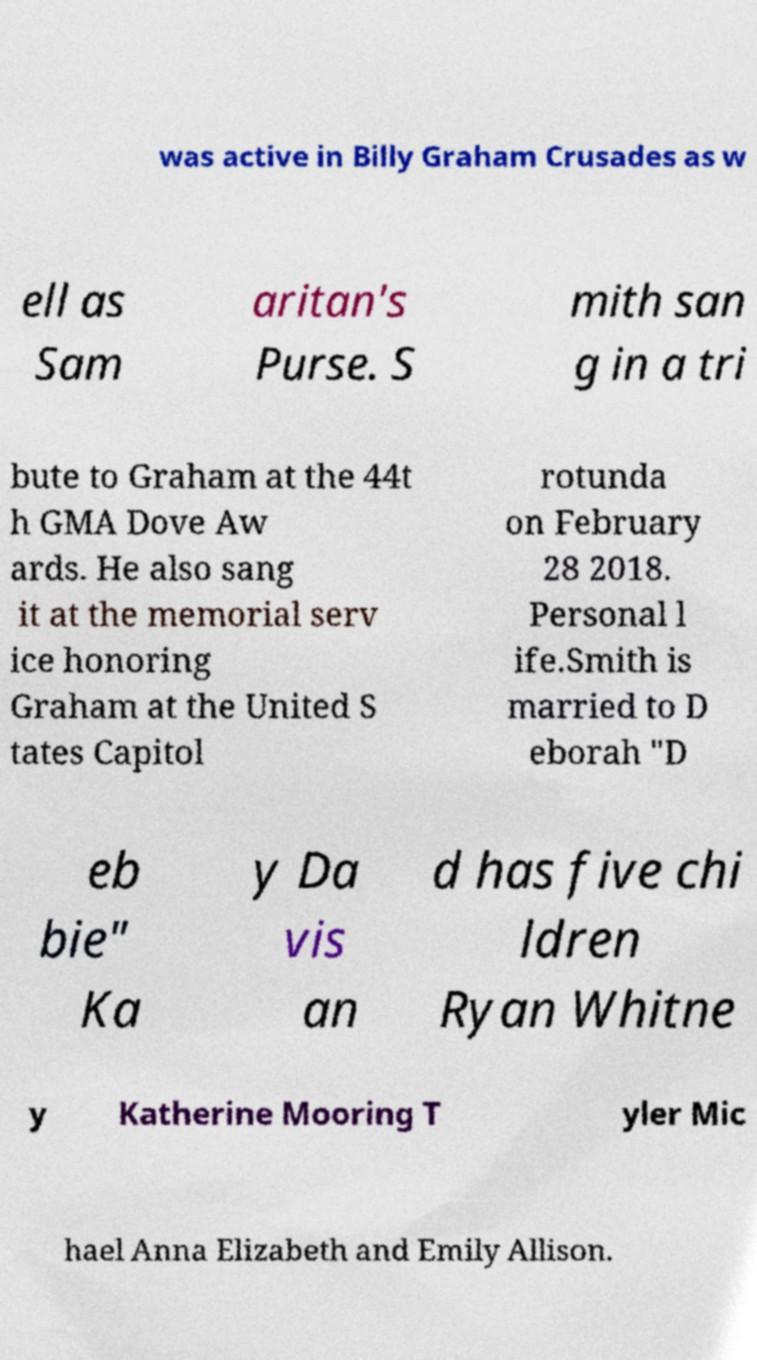Please read and relay the text visible in this image. What does it say? was active in Billy Graham Crusades as w ell as Sam aritan's Purse. S mith san g in a tri bute to Graham at the 44t h GMA Dove Aw ards. He also sang it at the memorial serv ice honoring Graham at the United S tates Capitol rotunda on February 28 2018. Personal l ife.Smith is married to D eborah "D eb bie" Ka y Da vis an d has five chi ldren Ryan Whitne y Katherine Mooring T yler Mic hael Anna Elizabeth and Emily Allison. 